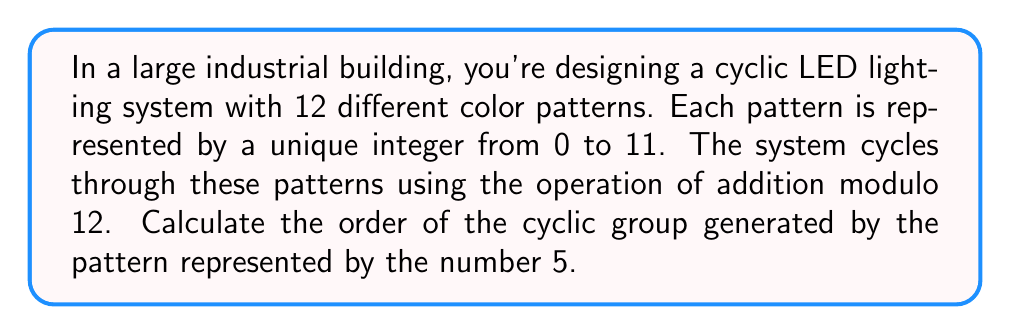Provide a solution to this math problem. To solve this problem, we need to understand the concept of cyclic groups and how to calculate their order. In this case, we're dealing with a group of color patterns under the operation of addition modulo 12.

1) First, let's recall that in a cyclic group, the order of an element is the smallest positive integer $n$ such that $a^n = e$, where $e$ is the identity element and $a$ is the generating element.

2) In our case, we're using addition modulo 12, so the operation is:
   $$(5 + 5 + ... + 5) \bmod 12$$
   where 5 is added $n$ times.

3) We need to find the smallest positive $n$ such that:
   $$5n \equiv 0 \pmod{12}$$

4) We can solve this by listing out the multiples of 5 modulo 12:
   $$5 \equiv 5 \pmod{12}$$
   $$10 \equiv 10 \pmod{12}$$
   $$15 \equiv 3 \pmod{12}$$
   $$20 \equiv 8 \pmod{12}$$
   $$25 \equiv 1 \pmod{12}$$
   $$30 \equiv 6 \pmod{12}$$
   $$35 \equiv 11 \pmod{12}$$
   $$40 \equiv 4 \pmod{12}$$
   $$45 \equiv 9 \pmod{12}$$
   $$50 \equiv 2 \pmod{12}$$
   $$55 \equiv 7 \pmod{12}$$
   $$60 \equiv 0 \pmod{12}$$

5) We see that it takes 12 steps to reach 0 (the identity element in this group).

Therefore, the order of the cyclic group generated by the pattern represented by 5 is 12.
Answer: The order of the cyclic group is 12. 